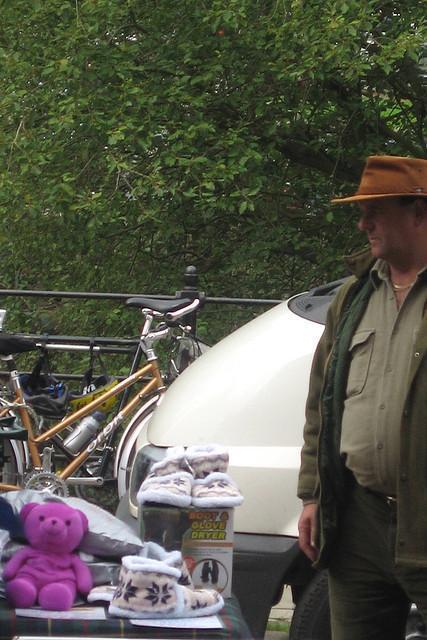How many bears are there?
Give a very brief answer. 1. How many bicycles can be seen?
Give a very brief answer. 2. How many of the people on the bench are holding umbrellas ?
Give a very brief answer. 0. 